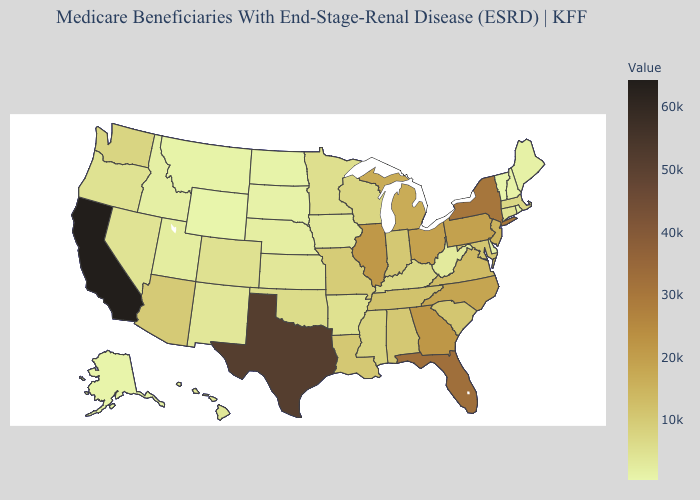Among the states that border Utah , which have the lowest value?
Short answer required. Wyoming. Does Tennessee have a higher value than Nebraska?
Keep it brief. Yes. Which states have the lowest value in the USA?
Keep it brief. Wyoming. Which states have the highest value in the USA?
Concise answer only. California. Which states hav the highest value in the Northeast?
Concise answer only. New York. Among the states that border Vermont , does Massachusetts have the lowest value?
Be succinct. No. 